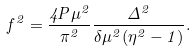<formula> <loc_0><loc_0><loc_500><loc_500>f ^ { 2 } = \frac { 4 P \mu ^ { 2 } } { \pi ^ { 2 } } \frac { \Delta ^ { 2 } } { \delta \mu ^ { 2 } ( \eta ^ { 2 } - 1 ) } .</formula> 